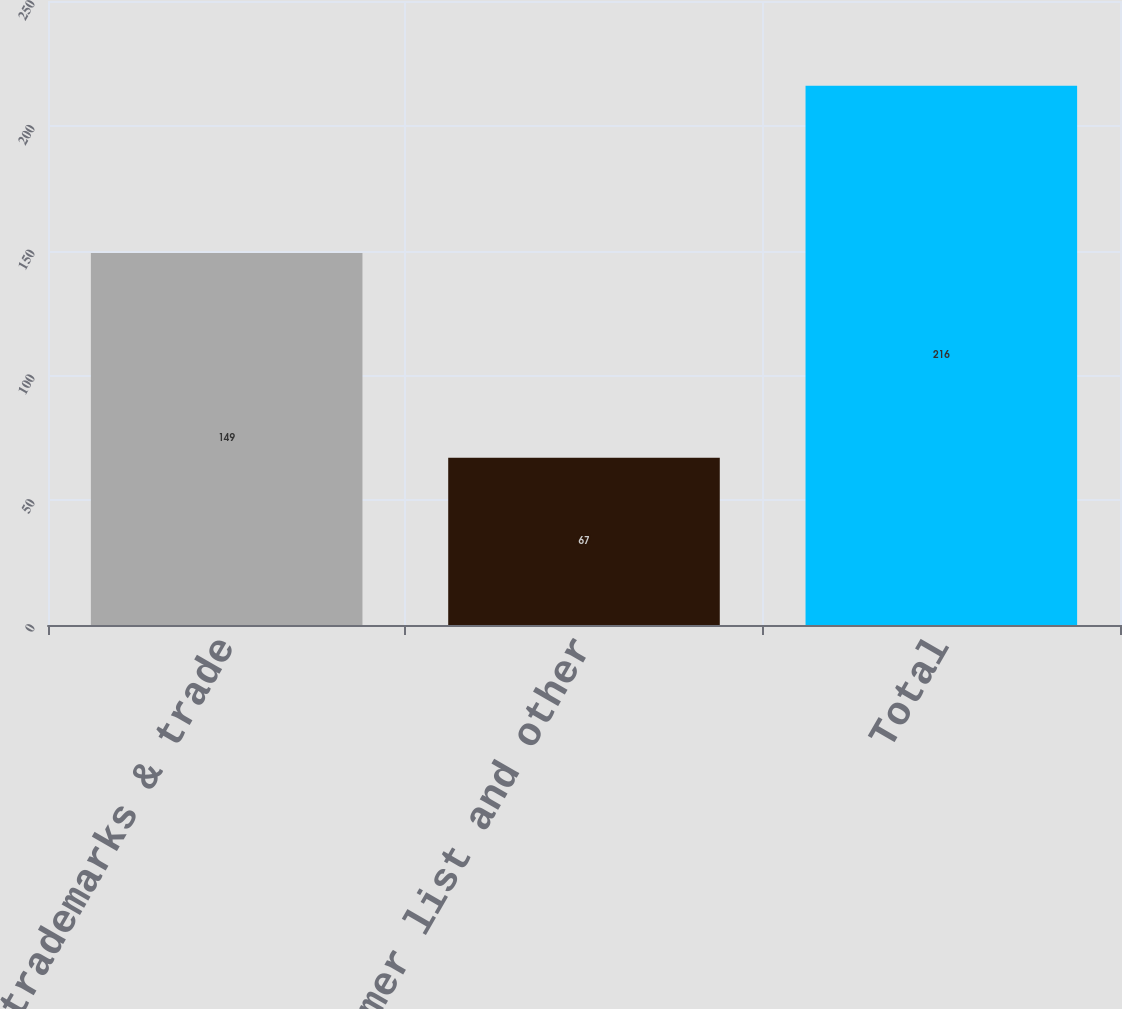Convert chart. <chart><loc_0><loc_0><loc_500><loc_500><bar_chart><fcel>Patents trademarks & trade<fcel>Customer list and other<fcel>Total<nl><fcel>149<fcel>67<fcel>216<nl></chart> 